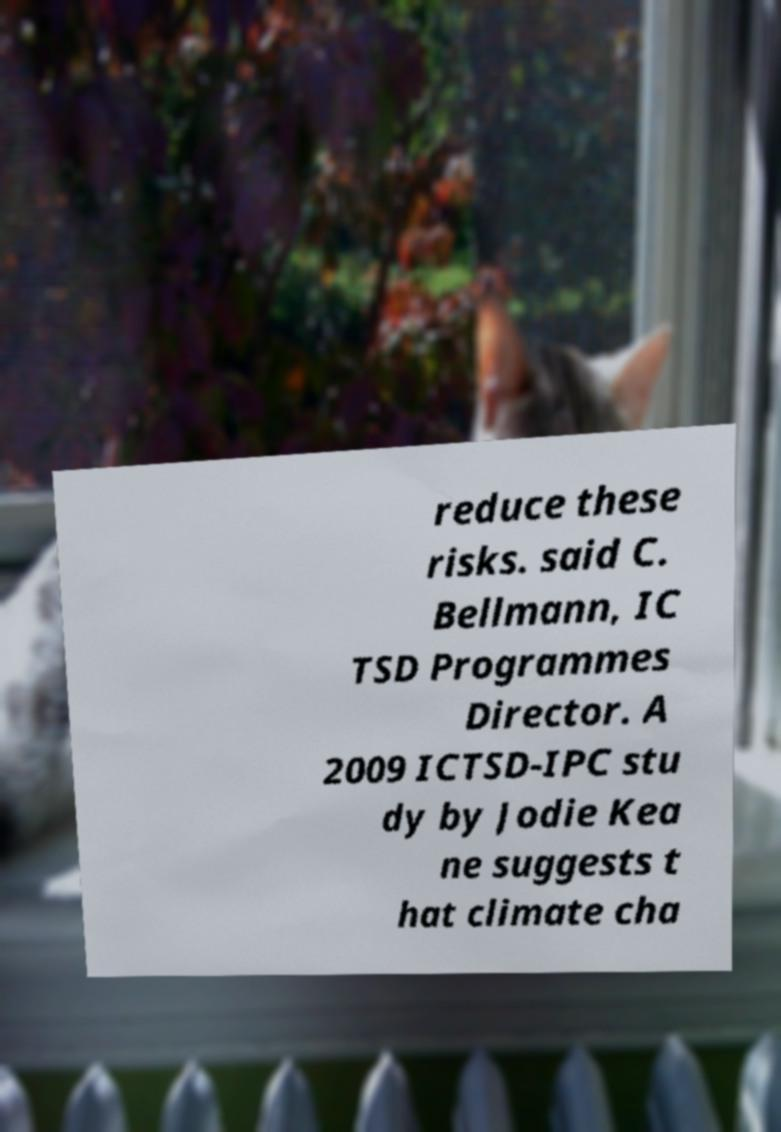There's text embedded in this image that I need extracted. Can you transcribe it verbatim? reduce these risks. said C. Bellmann, IC TSD Programmes Director. A 2009 ICTSD-IPC stu dy by Jodie Kea ne suggests t hat climate cha 